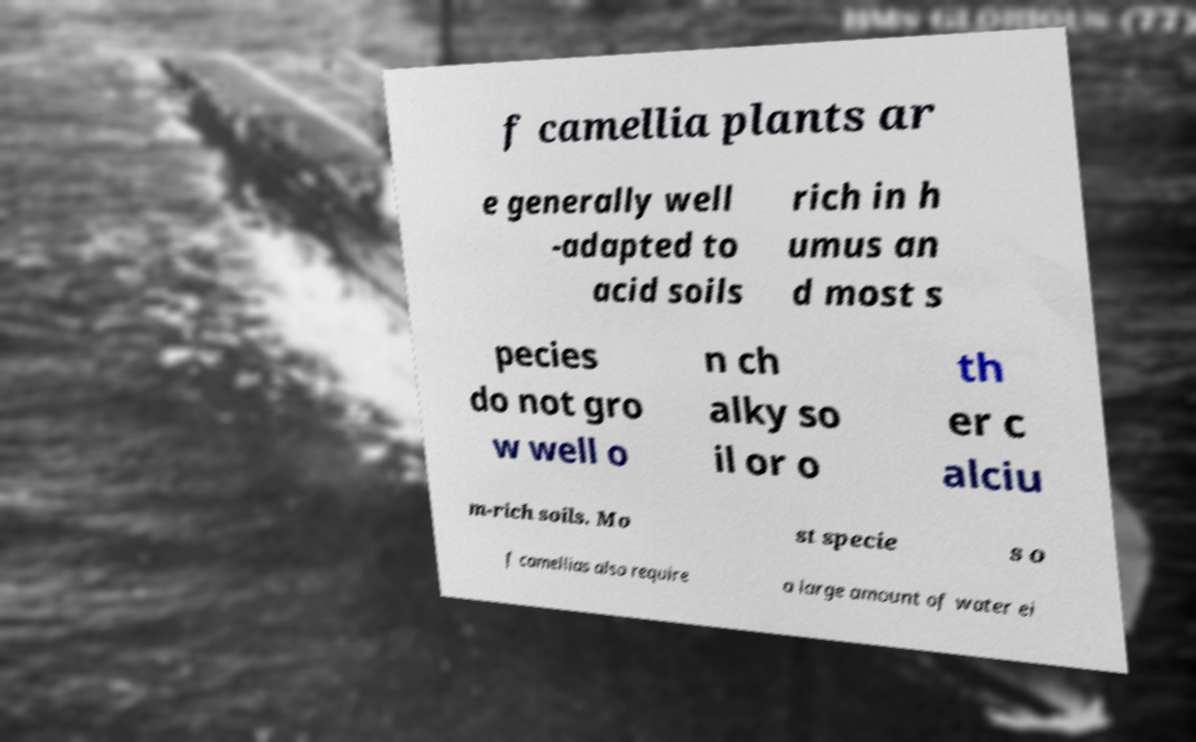There's text embedded in this image that I need extracted. Can you transcribe it verbatim? f camellia plants ar e generally well -adapted to acid soils rich in h umus an d most s pecies do not gro w well o n ch alky so il or o th er c alciu m-rich soils. Mo st specie s o f camellias also require a large amount of water ei 